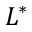<formula> <loc_0><loc_0><loc_500><loc_500>L ^ { * }</formula> 